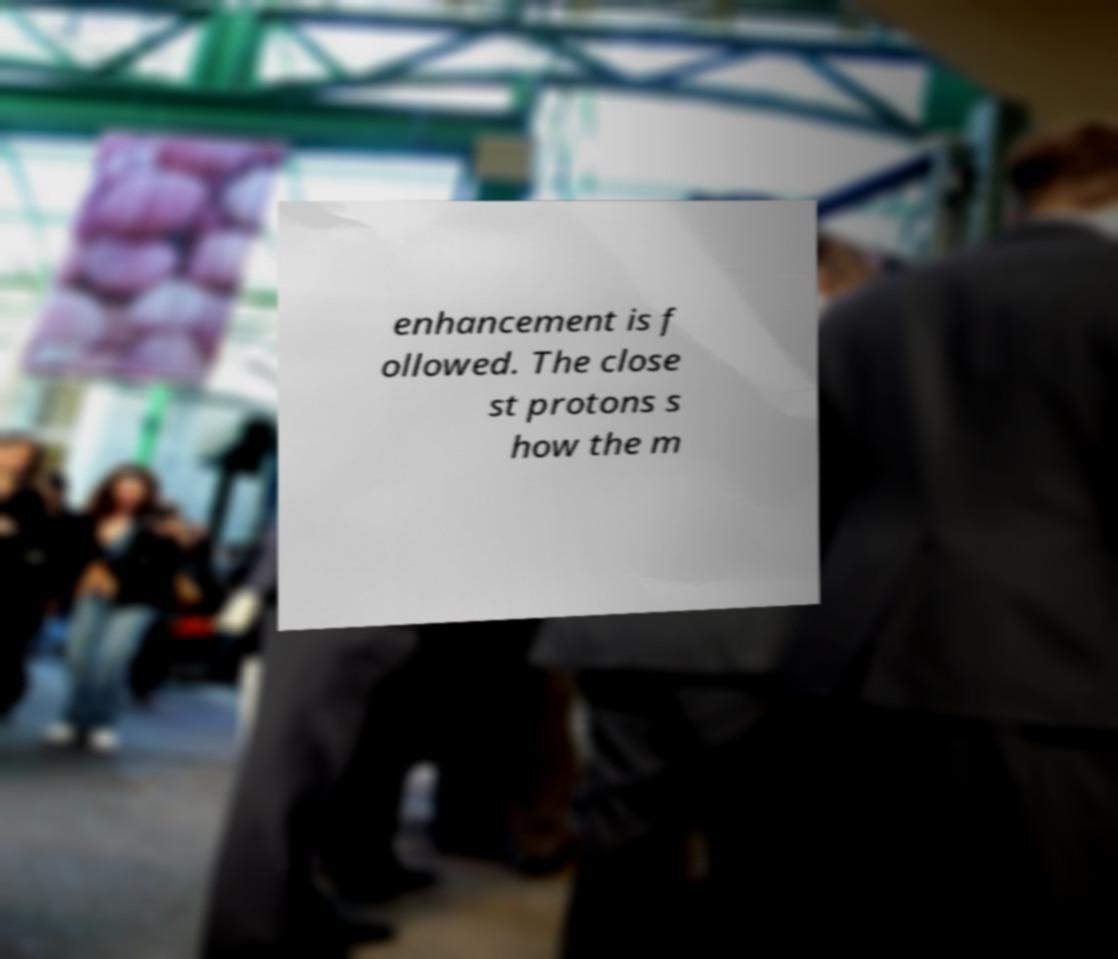I need the written content from this picture converted into text. Can you do that? enhancement is f ollowed. The close st protons s how the m 